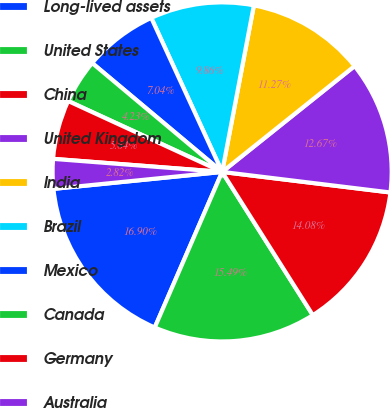Convert chart to OTSL. <chart><loc_0><loc_0><loc_500><loc_500><pie_chart><fcel>Long-lived assets<fcel>United States<fcel>China<fcel>United Kingdom<fcel>India<fcel>Brazil<fcel>Mexico<fcel>Canada<fcel>Germany<fcel>Australia<nl><fcel>16.9%<fcel>15.49%<fcel>14.08%<fcel>12.67%<fcel>11.27%<fcel>9.86%<fcel>7.04%<fcel>4.23%<fcel>5.64%<fcel>2.82%<nl></chart> 